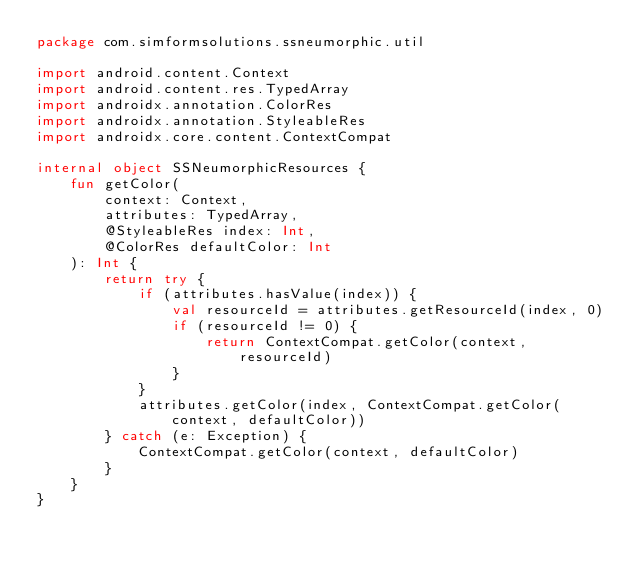Convert code to text. <code><loc_0><loc_0><loc_500><loc_500><_Kotlin_>package com.simformsolutions.ssneumorphic.util

import android.content.Context
import android.content.res.TypedArray
import androidx.annotation.ColorRes
import androidx.annotation.StyleableRes
import androidx.core.content.ContextCompat

internal object SSNeumorphicResources {
    fun getColor(
        context: Context,
        attributes: TypedArray,
        @StyleableRes index: Int,
        @ColorRes defaultColor: Int
    ): Int {
        return try {
            if (attributes.hasValue(index)) {
                val resourceId = attributes.getResourceId(index, 0)
                if (resourceId != 0) {
                    return ContextCompat.getColor(context, resourceId)
                }
            }
            attributes.getColor(index, ContextCompat.getColor(context, defaultColor))
        } catch (e: Exception) {
            ContextCompat.getColor(context, defaultColor)
        }
    }
}
</code> 